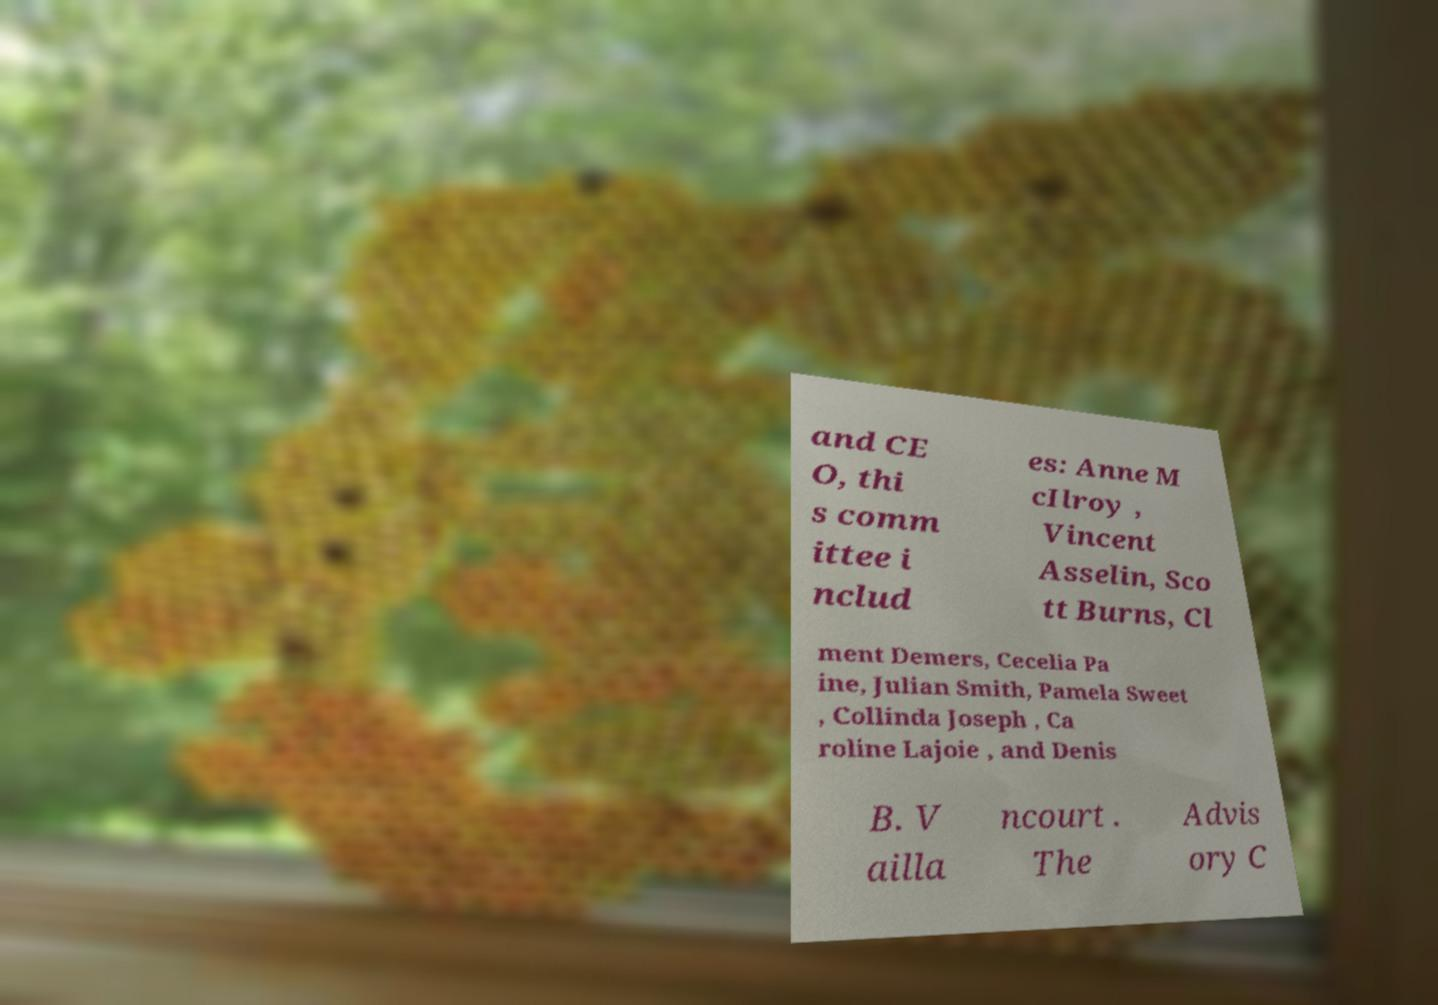Can you read and provide the text displayed in the image?This photo seems to have some interesting text. Can you extract and type it out for me? and CE O, thi s comm ittee i nclud es: Anne M cIlroy , Vincent Asselin, Sco tt Burns, Cl ment Demers, Cecelia Pa ine, Julian Smith, Pamela Sweet , Collinda Joseph , Ca roline Lajoie , and Denis B. V ailla ncourt . The Advis ory C 